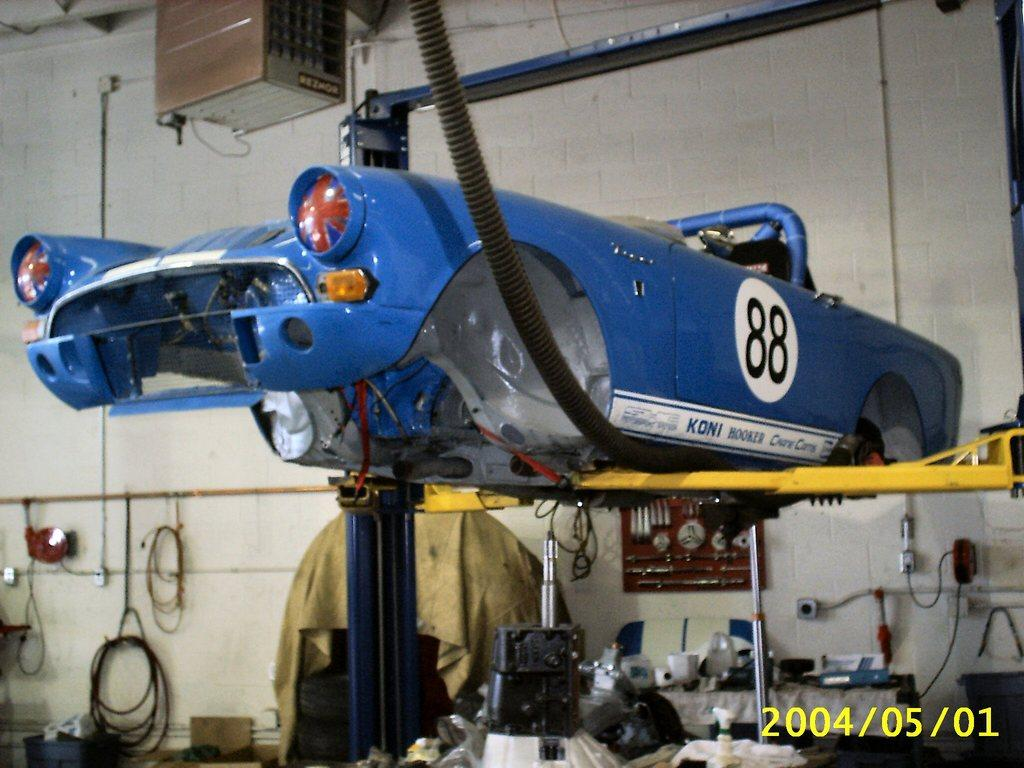<image>
Present a compact description of the photo's key features. An old racing car with a KONI sticker on the side is in a service center. 